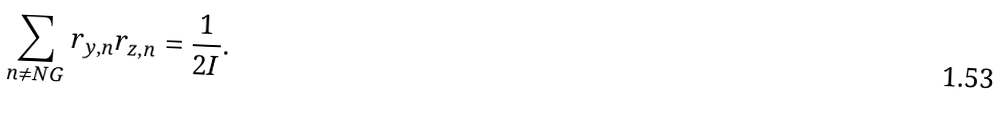<formula> <loc_0><loc_0><loc_500><loc_500>\sum _ { n \neq N G } r _ { y , n } r _ { z , n } = \frac { 1 } { 2 I } .</formula> 